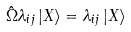Convert formula to latex. <formula><loc_0><loc_0><loc_500><loc_500>\hat { \Omega } \lambda _ { i j } \, | X \rangle = \lambda _ { i j } \, | X \rangle</formula> 